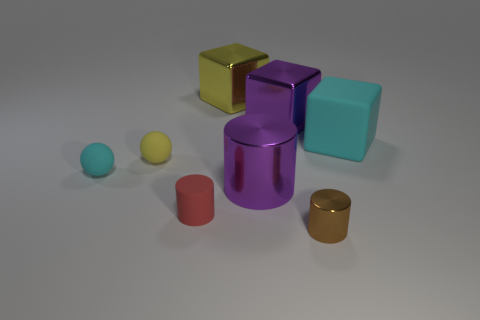Subtract all rubber cylinders. How many cylinders are left? 2 Add 1 large gray cylinders. How many objects exist? 9 Subtract 1 balls. How many balls are left? 1 Subtract all yellow cubes. How many cubes are left? 2 Subtract all purple balls. How many purple blocks are left? 1 Subtract all cylinders. How many objects are left? 5 Subtract all big yellow shiny cubes. Subtract all brown cylinders. How many objects are left? 6 Add 8 small matte spheres. How many small matte spheres are left? 10 Add 8 rubber balls. How many rubber balls exist? 10 Subtract 0 brown spheres. How many objects are left? 8 